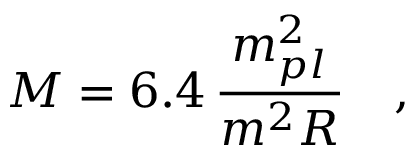Convert formula to latex. <formula><loc_0><loc_0><loc_500><loc_500>M = 6 . 4 \, \frac { m _ { p l } ^ { 2 } } { m ^ { 2 } R } \quad ,</formula> 